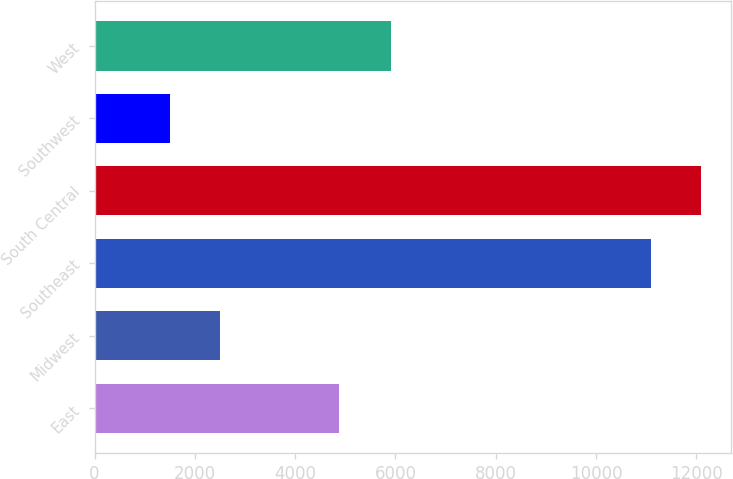Convert chart. <chart><loc_0><loc_0><loc_500><loc_500><bar_chart><fcel>East<fcel>Midwest<fcel>Southeast<fcel>South Central<fcel>Southwest<fcel>West<nl><fcel>4880<fcel>2494.6<fcel>11093<fcel>12088.6<fcel>1499<fcel>5910<nl></chart> 